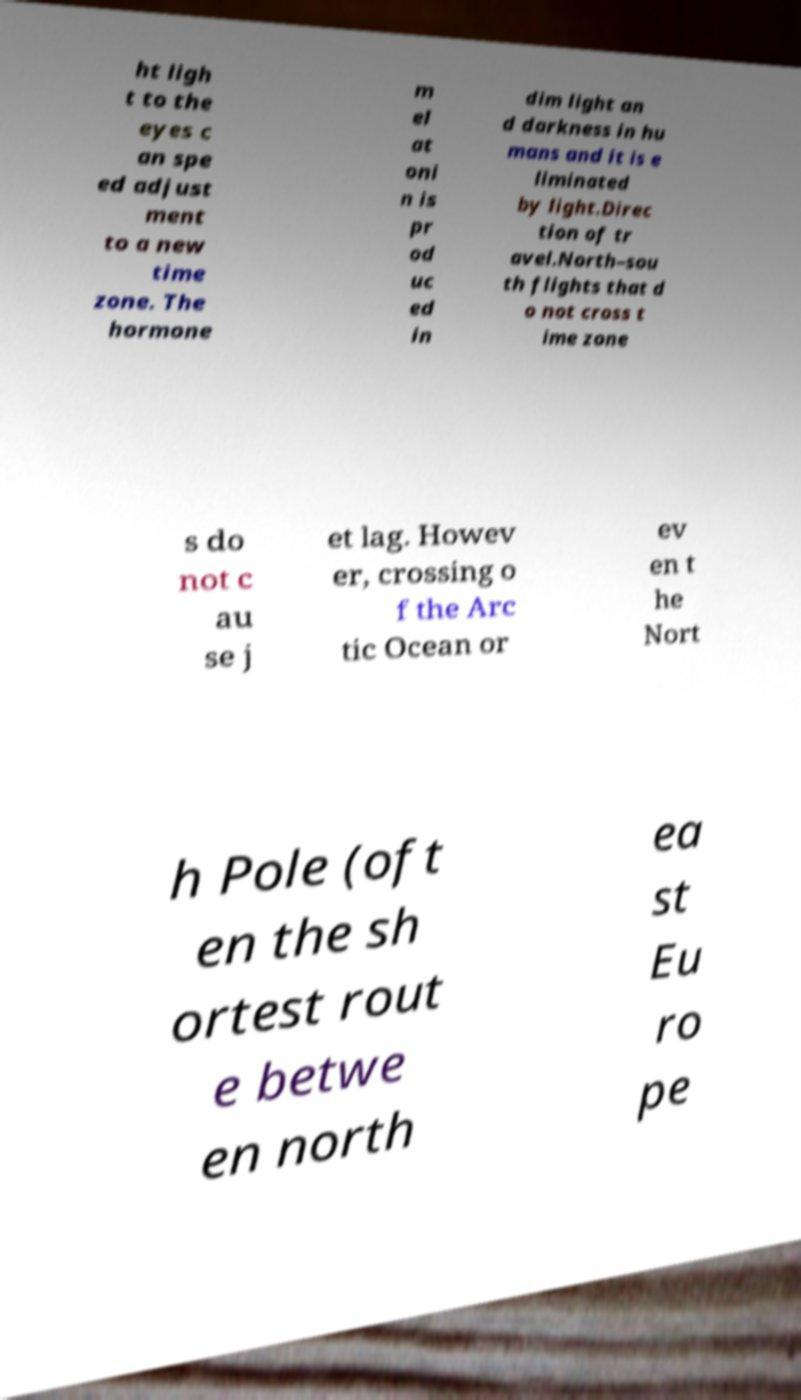Please identify and transcribe the text found in this image. ht ligh t to the eyes c an spe ed adjust ment to a new time zone. The hormone m el at oni n is pr od uc ed in dim light an d darkness in hu mans and it is e liminated by light.Direc tion of tr avel.North–sou th flights that d o not cross t ime zone s do not c au se j et lag. Howev er, crossing o f the Arc tic Ocean or ev en t he Nort h Pole (oft en the sh ortest rout e betwe en north ea st Eu ro pe 